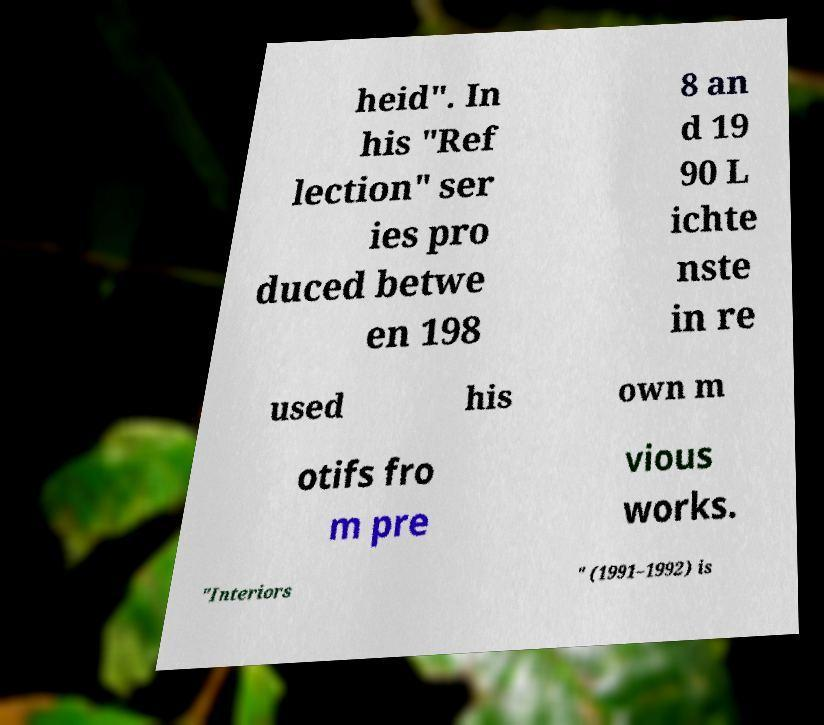I need the written content from this picture converted into text. Can you do that? heid". In his "Ref lection" ser ies pro duced betwe en 198 8 an d 19 90 L ichte nste in re used his own m otifs fro m pre vious works. "Interiors " (1991–1992) is 